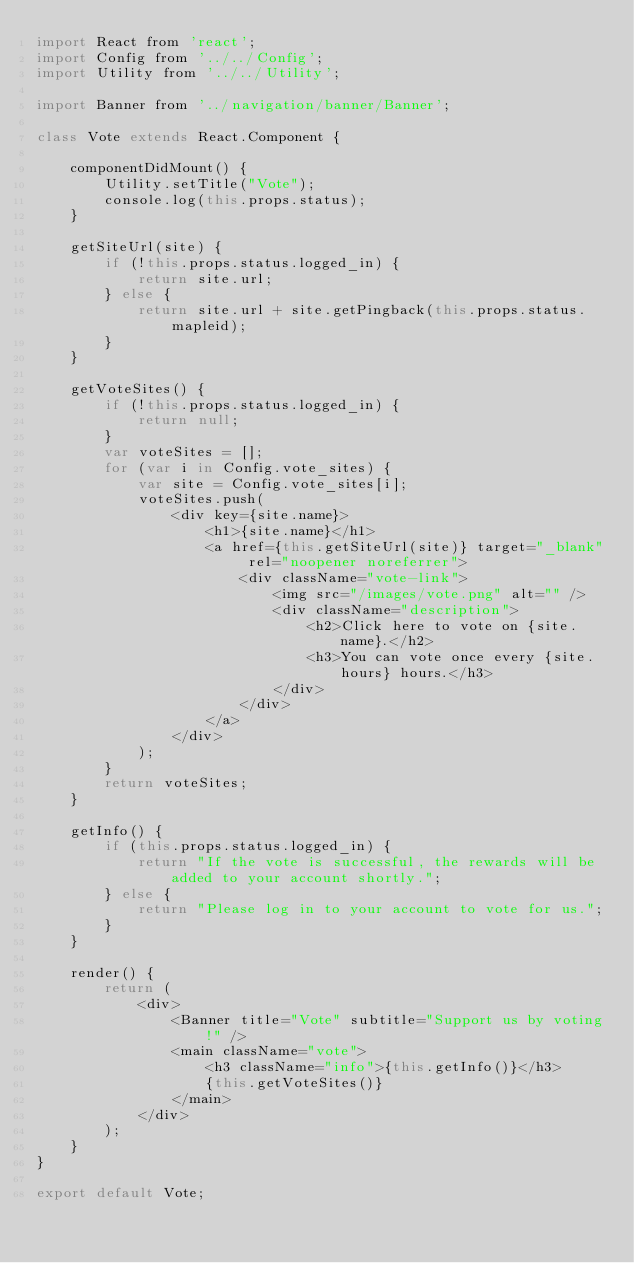<code> <loc_0><loc_0><loc_500><loc_500><_JavaScript_>import React from 'react';
import Config from '../../Config';
import Utility from '../../Utility';

import Banner from '../navigation/banner/Banner';

class Vote extends React.Component {

    componentDidMount() {
        Utility.setTitle("Vote");
        console.log(this.props.status);
    }

    getSiteUrl(site) {
        if (!this.props.status.logged_in) {
            return site.url;
        } else {
            return site.url + site.getPingback(this.props.status.mapleid);
        }
    }

    getVoteSites() {
        if (!this.props.status.logged_in) {
            return null;
        }
        var voteSites = [];
        for (var i in Config.vote_sites) {
            var site = Config.vote_sites[i];
            voteSites.push(
                <div key={site.name}>
                    <h1>{site.name}</h1>
                    <a href={this.getSiteUrl(site)} target="_blank" rel="noopener noreferrer">
                        <div className="vote-link">
                            <img src="/images/vote.png" alt="" />
                            <div className="description">
                                <h2>Click here to vote on {site.name}.</h2>
                                <h3>You can vote once every {site.hours} hours.</h3>
                            </div>
                        </div>
                    </a>
                </div>
            );
        }
        return voteSites;
    }

    getInfo() {
        if (this.props.status.logged_in) {
            return "If the vote is successful, the rewards will be added to your account shortly.";
        } else {
            return "Please log in to your account to vote for us.";
        }
    }

    render() {
        return (
            <div>
                <Banner title="Vote" subtitle="Support us by voting!" />
                <main className="vote">
                    <h3 className="info">{this.getInfo()}</h3>
                    {this.getVoteSites()}
                </main>
            </div>
        );
    }
}

export default Vote;
</code> 